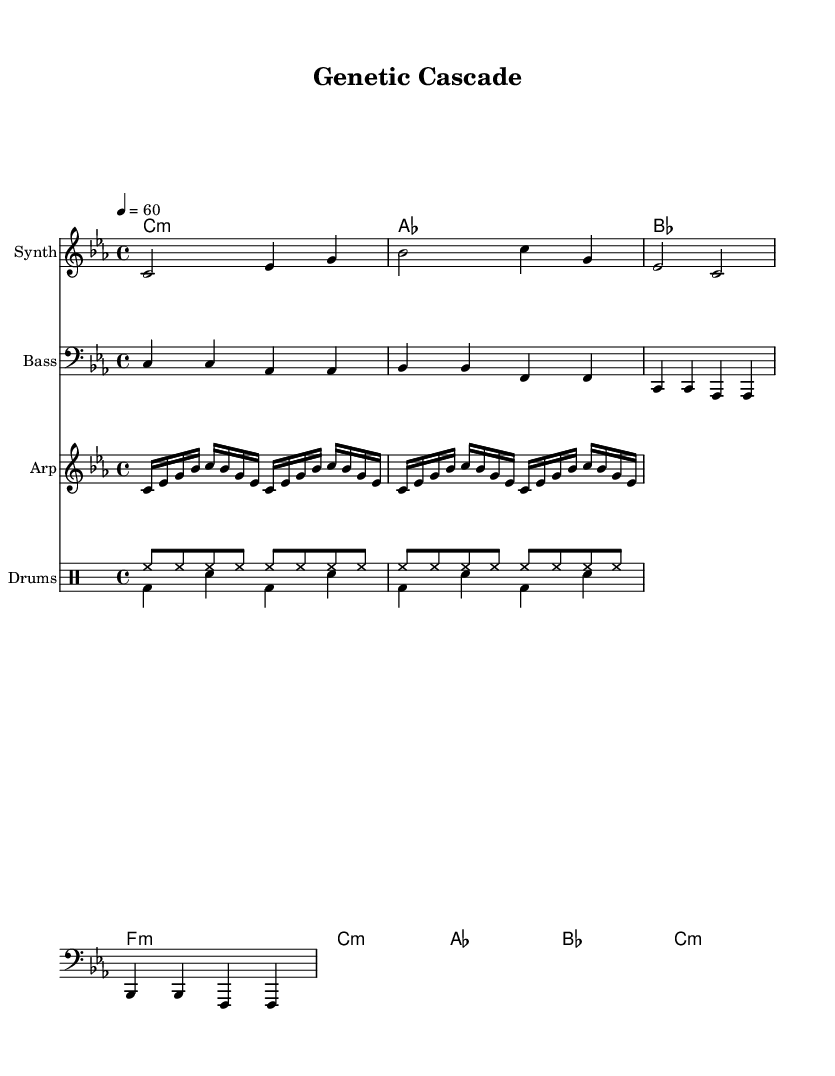What is the key signature of this music? The key signature is C minor, which has three flats (B♭, E♭, A♭). This is indicated at the beginning of the staff.
Answer: C minor What is the time signature of this piece? The time signature is 4/4, which indicates there are four beats in each measure. This is seen at the start of the score, right after the key signature.
Answer: 4/4 What is the tempo marking for the piece? The tempo marking is 60 BPM, as indicated by the tempo indication at the beginning of the score.
Answer: 60 How many measures are in the melody section? The melody section consists of 3 measures, identifiable by the grouping of notes with bar lines.
Answer: 3 In which instrument is the melody primarily played? The melody is primarily played on the Synth, as indicated by the label in the score.
Answer: Synth What rhythmic pattern do the drums create in the "drumsUp" section? The "drumsUp" section consists of a consistent eighth-note pattern, as shown by the repeated hi-hat notations.
Answer: Eighth notes What type of chord progression is used in the harmonies section? The harmonies section employs a minor chord progression, which is characteristic of ambient and electronic music. This is deduced from the chord symbols written in the score.
Answer: Minor chords 